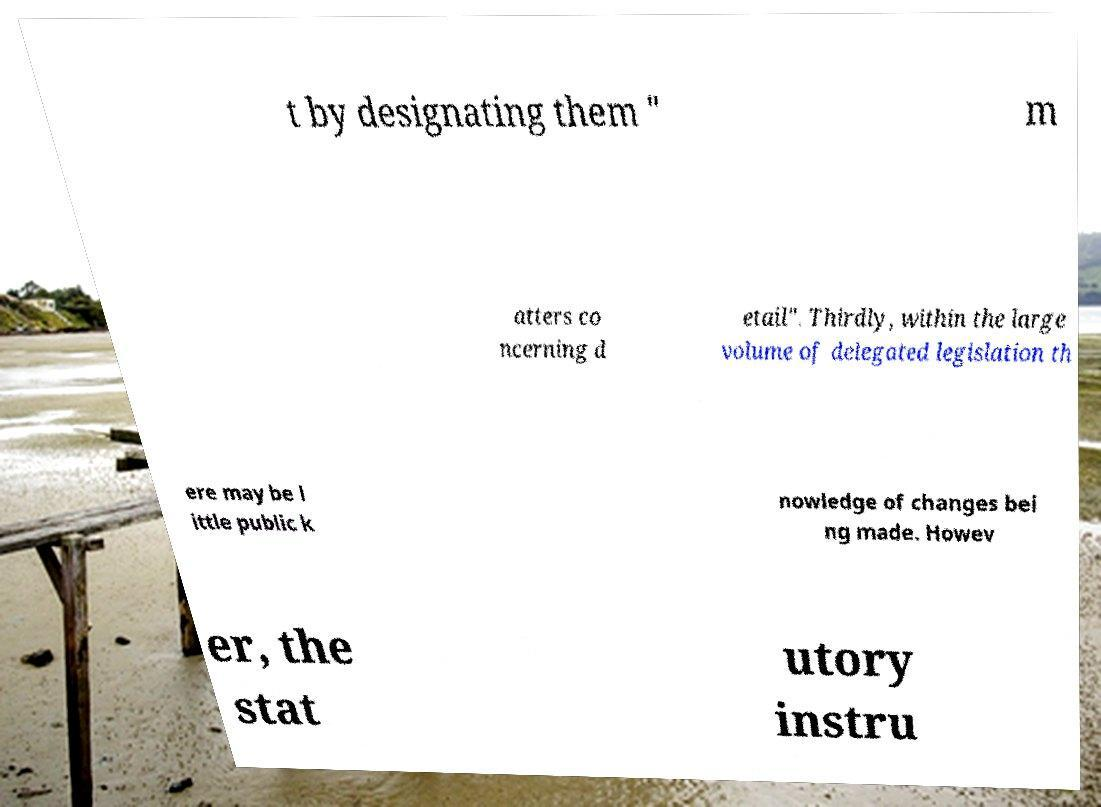Please read and relay the text visible in this image. What does it say? t by designating them " m atters co ncerning d etail". Thirdly, within the large volume of delegated legislation th ere may be l ittle public k nowledge of changes bei ng made. Howev er, the stat utory instru 